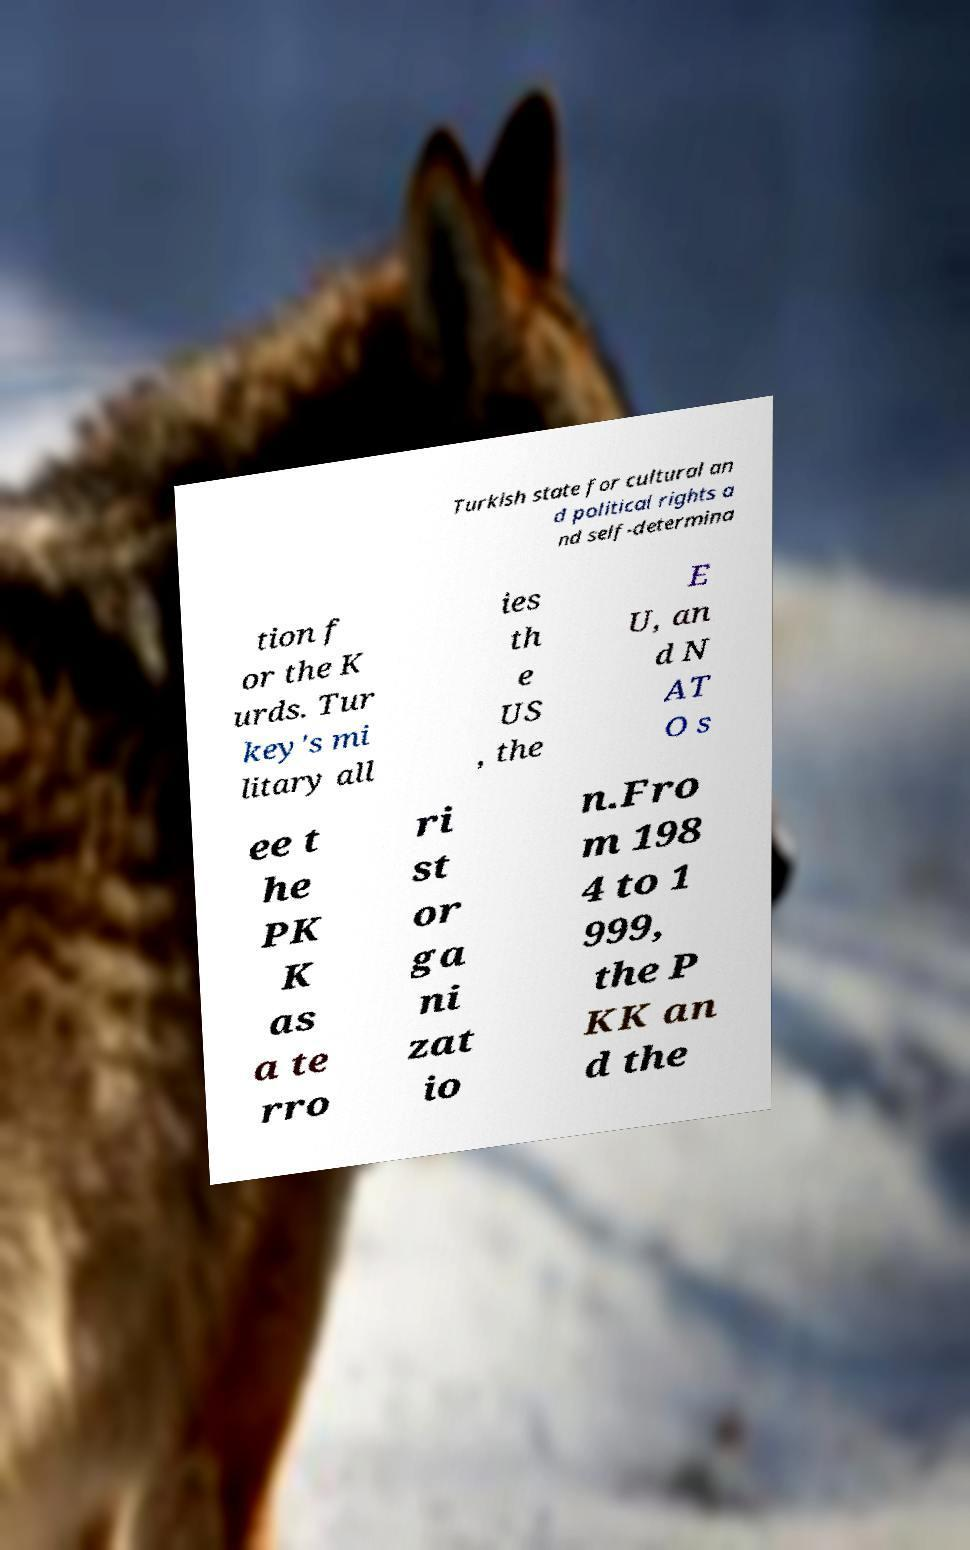There's text embedded in this image that I need extracted. Can you transcribe it verbatim? Turkish state for cultural an d political rights a nd self-determina tion f or the K urds. Tur key's mi litary all ies th e US , the E U, an d N AT O s ee t he PK K as a te rro ri st or ga ni zat io n.Fro m 198 4 to 1 999, the P KK an d the 